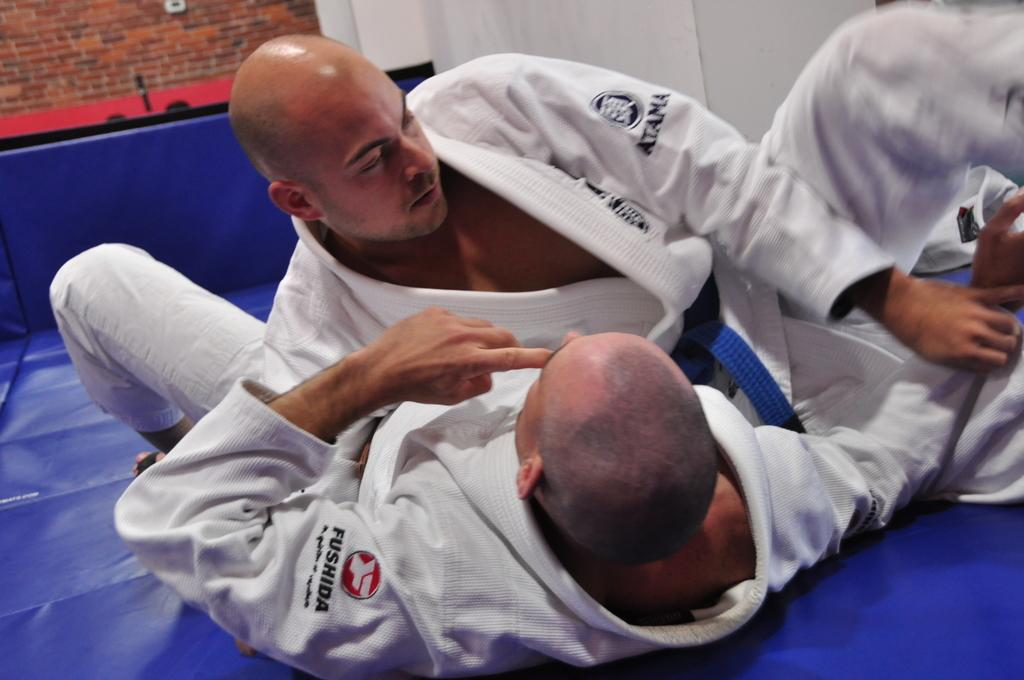How many people are in the image? There are two persons in the image. What are the persons wearing? The persons are wearing white dresses. What is the color of the surface they are lying on? The persons are lying on a blue surface. What can be seen in the background of the image? There is a wall in the background of the image, and it is a brick wall. What grade is the carriage in the image? There is no carriage present in the image. On which throne are the persons sitting in the image? There is no throne present in the image; the persons are lying on a blue surface. 